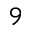Convert formula to latex. <formula><loc_0><loc_0><loc_500><loc_500>^ { 9 }</formula> 